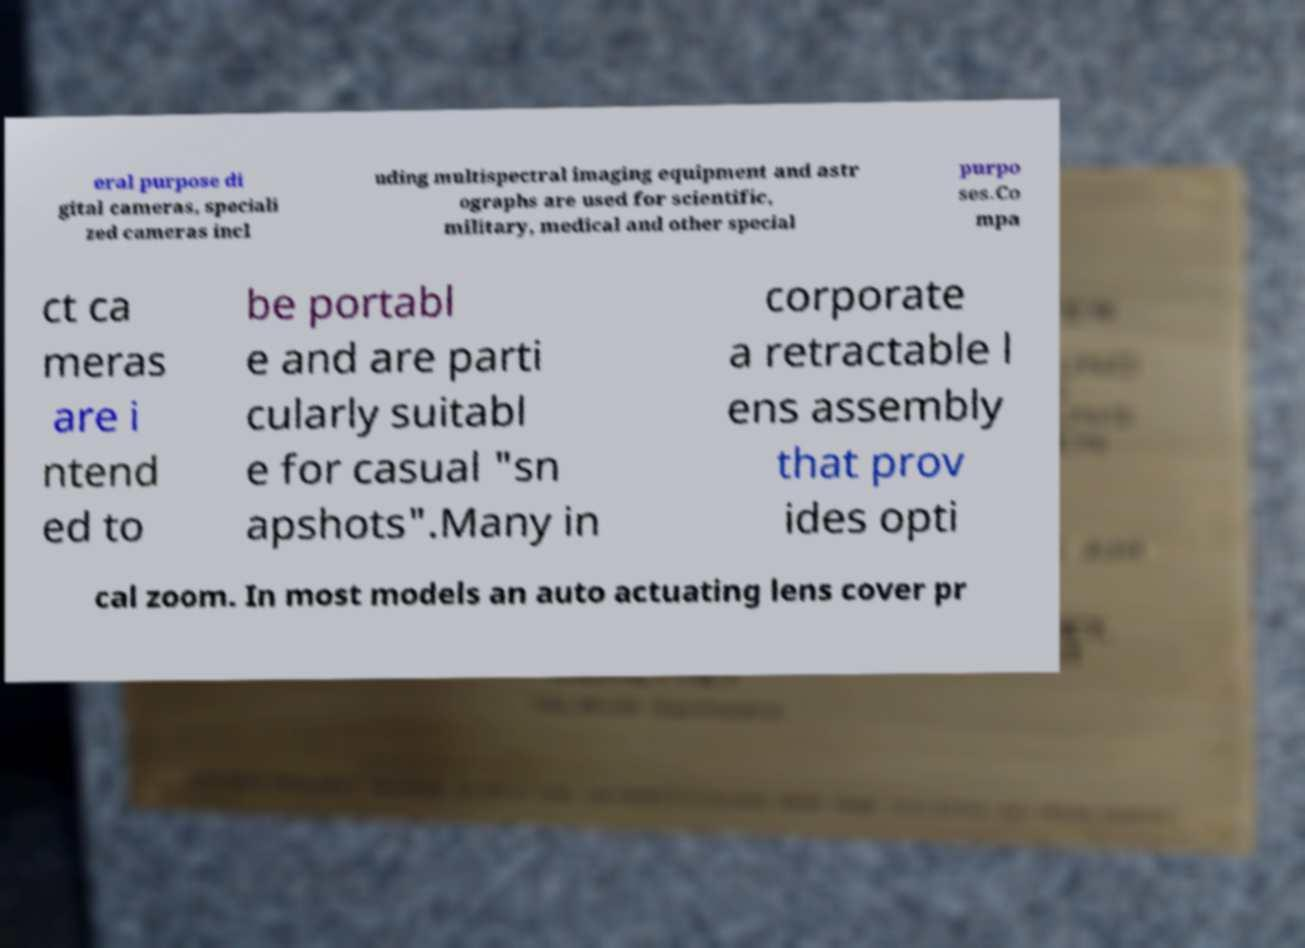There's text embedded in this image that I need extracted. Can you transcribe it verbatim? eral purpose di gital cameras, speciali zed cameras incl uding multispectral imaging equipment and astr ographs are used for scientific, military, medical and other special purpo ses.Co mpa ct ca meras are i ntend ed to be portabl e and are parti cularly suitabl e for casual "sn apshots".Many in corporate a retractable l ens assembly that prov ides opti cal zoom. In most models an auto actuating lens cover pr 